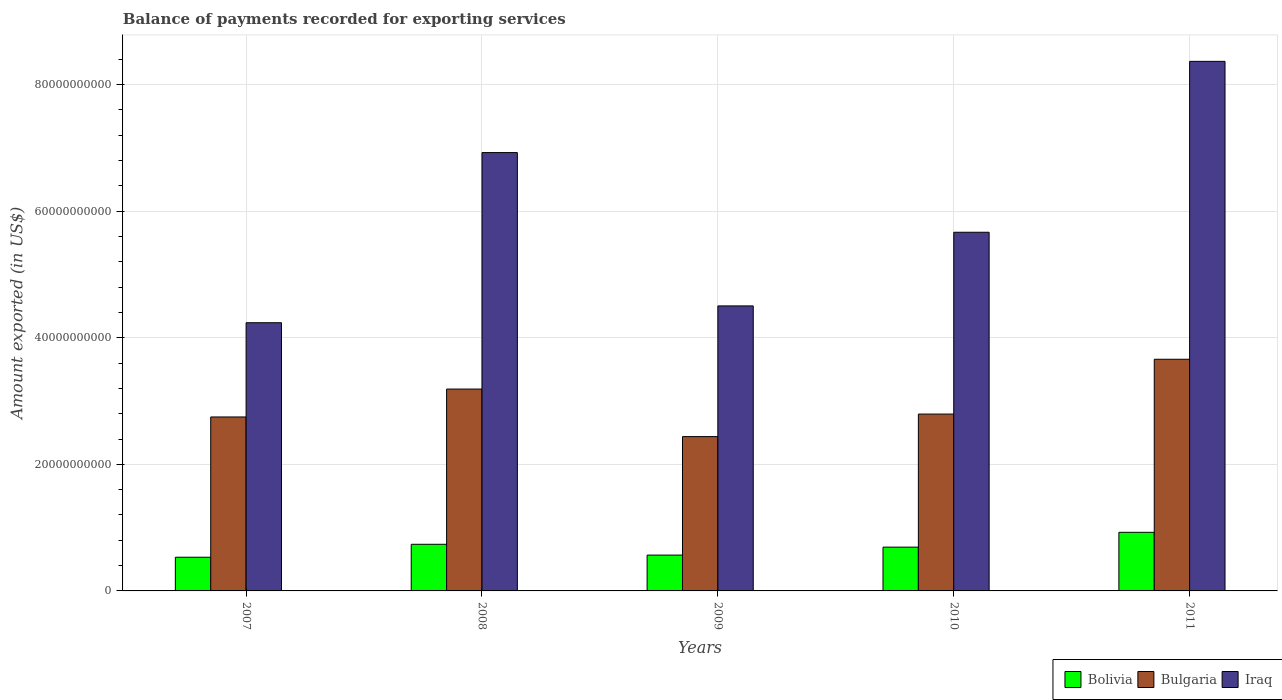Are the number of bars per tick equal to the number of legend labels?
Your answer should be compact. Yes. Are the number of bars on each tick of the X-axis equal?
Provide a short and direct response. Yes. What is the amount exported in Bolivia in 2008?
Keep it short and to the point. 7.37e+09. Across all years, what is the maximum amount exported in Bulgaria?
Provide a short and direct response. 3.66e+1. Across all years, what is the minimum amount exported in Bolivia?
Keep it short and to the point. 5.32e+09. In which year was the amount exported in Bulgaria maximum?
Offer a very short reply. 2011. What is the total amount exported in Bulgaria in the graph?
Your answer should be very brief. 1.48e+11. What is the difference between the amount exported in Bolivia in 2007 and that in 2009?
Offer a very short reply. -3.38e+08. What is the difference between the amount exported in Bulgaria in 2007 and the amount exported in Iraq in 2009?
Ensure brevity in your answer.  -1.75e+1. What is the average amount exported in Bolivia per year?
Your response must be concise. 6.91e+09. In the year 2007, what is the difference between the amount exported in Bolivia and amount exported in Iraq?
Your response must be concise. -3.71e+1. What is the ratio of the amount exported in Iraq in 2010 to that in 2011?
Keep it short and to the point. 0.68. Is the amount exported in Bulgaria in 2007 less than that in 2008?
Make the answer very short. Yes. Is the difference between the amount exported in Bolivia in 2007 and 2010 greater than the difference between the amount exported in Iraq in 2007 and 2010?
Make the answer very short. Yes. What is the difference between the highest and the second highest amount exported in Iraq?
Provide a succinct answer. 1.44e+1. What is the difference between the highest and the lowest amount exported in Iraq?
Give a very brief answer. 4.13e+1. What does the 3rd bar from the left in 2011 represents?
Ensure brevity in your answer.  Iraq. What does the 1st bar from the right in 2011 represents?
Provide a short and direct response. Iraq. Are the values on the major ticks of Y-axis written in scientific E-notation?
Provide a succinct answer. No. Does the graph contain grids?
Your answer should be very brief. Yes. How are the legend labels stacked?
Provide a succinct answer. Horizontal. What is the title of the graph?
Give a very brief answer. Balance of payments recorded for exporting services. What is the label or title of the Y-axis?
Make the answer very short. Amount exported (in US$). What is the Amount exported (in US$) of Bolivia in 2007?
Give a very brief answer. 5.32e+09. What is the Amount exported (in US$) in Bulgaria in 2007?
Your answer should be very brief. 2.75e+1. What is the Amount exported (in US$) in Iraq in 2007?
Offer a terse response. 4.24e+1. What is the Amount exported (in US$) of Bolivia in 2008?
Give a very brief answer. 7.37e+09. What is the Amount exported (in US$) of Bulgaria in 2008?
Your answer should be very brief. 3.19e+1. What is the Amount exported (in US$) in Iraq in 2008?
Make the answer very short. 6.93e+1. What is the Amount exported (in US$) in Bolivia in 2009?
Offer a terse response. 5.66e+09. What is the Amount exported (in US$) in Bulgaria in 2009?
Provide a short and direct response. 2.44e+1. What is the Amount exported (in US$) in Iraq in 2009?
Your answer should be very brief. 4.50e+1. What is the Amount exported (in US$) of Bolivia in 2010?
Provide a succinct answer. 6.92e+09. What is the Amount exported (in US$) in Bulgaria in 2010?
Ensure brevity in your answer.  2.79e+1. What is the Amount exported (in US$) of Iraq in 2010?
Your answer should be compact. 5.67e+1. What is the Amount exported (in US$) in Bolivia in 2011?
Give a very brief answer. 9.26e+09. What is the Amount exported (in US$) of Bulgaria in 2011?
Make the answer very short. 3.66e+1. What is the Amount exported (in US$) in Iraq in 2011?
Your response must be concise. 8.37e+1. Across all years, what is the maximum Amount exported (in US$) of Bolivia?
Your answer should be very brief. 9.26e+09. Across all years, what is the maximum Amount exported (in US$) of Bulgaria?
Your answer should be very brief. 3.66e+1. Across all years, what is the maximum Amount exported (in US$) of Iraq?
Ensure brevity in your answer.  8.37e+1. Across all years, what is the minimum Amount exported (in US$) of Bolivia?
Give a very brief answer. 5.32e+09. Across all years, what is the minimum Amount exported (in US$) in Bulgaria?
Your answer should be compact. 2.44e+1. Across all years, what is the minimum Amount exported (in US$) of Iraq?
Give a very brief answer. 4.24e+1. What is the total Amount exported (in US$) in Bolivia in the graph?
Offer a very short reply. 3.45e+1. What is the total Amount exported (in US$) in Bulgaria in the graph?
Provide a succinct answer. 1.48e+11. What is the total Amount exported (in US$) in Iraq in the graph?
Give a very brief answer. 2.97e+11. What is the difference between the Amount exported (in US$) of Bolivia in 2007 and that in 2008?
Provide a succinct answer. -2.04e+09. What is the difference between the Amount exported (in US$) of Bulgaria in 2007 and that in 2008?
Offer a very short reply. -4.41e+09. What is the difference between the Amount exported (in US$) in Iraq in 2007 and that in 2008?
Give a very brief answer. -2.69e+1. What is the difference between the Amount exported (in US$) of Bolivia in 2007 and that in 2009?
Provide a succinct answer. -3.38e+08. What is the difference between the Amount exported (in US$) in Bulgaria in 2007 and that in 2009?
Make the answer very short. 3.10e+09. What is the difference between the Amount exported (in US$) of Iraq in 2007 and that in 2009?
Your answer should be very brief. -2.66e+09. What is the difference between the Amount exported (in US$) in Bolivia in 2007 and that in 2010?
Offer a terse response. -1.59e+09. What is the difference between the Amount exported (in US$) in Bulgaria in 2007 and that in 2010?
Keep it short and to the point. -4.56e+08. What is the difference between the Amount exported (in US$) in Iraq in 2007 and that in 2010?
Make the answer very short. -1.43e+1. What is the difference between the Amount exported (in US$) of Bolivia in 2007 and that in 2011?
Your response must be concise. -3.94e+09. What is the difference between the Amount exported (in US$) of Bulgaria in 2007 and that in 2011?
Your response must be concise. -9.12e+09. What is the difference between the Amount exported (in US$) in Iraq in 2007 and that in 2011?
Give a very brief answer. -4.13e+1. What is the difference between the Amount exported (in US$) in Bolivia in 2008 and that in 2009?
Your answer should be very brief. 1.71e+09. What is the difference between the Amount exported (in US$) of Bulgaria in 2008 and that in 2009?
Offer a very short reply. 7.51e+09. What is the difference between the Amount exported (in US$) in Iraq in 2008 and that in 2009?
Your response must be concise. 2.42e+1. What is the difference between the Amount exported (in US$) of Bolivia in 2008 and that in 2010?
Provide a short and direct response. 4.51e+08. What is the difference between the Amount exported (in US$) of Bulgaria in 2008 and that in 2010?
Offer a very short reply. 3.95e+09. What is the difference between the Amount exported (in US$) of Iraq in 2008 and that in 2010?
Give a very brief answer. 1.26e+1. What is the difference between the Amount exported (in US$) in Bolivia in 2008 and that in 2011?
Ensure brevity in your answer.  -1.89e+09. What is the difference between the Amount exported (in US$) in Bulgaria in 2008 and that in 2011?
Provide a short and direct response. -4.71e+09. What is the difference between the Amount exported (in US$) of Iraq in 2008 and that in 2011?
Your response must be concise. -1.44e+1. What is the difference between the Amount exported (in US$) in Bolivia in 2009 and that in 2010?
Your answer should be compact. -1.26e+09. What is the difference between the Amount exported (in US$) of Bulgaria in 2009 and that in 2010?
Provide a short and direct response. -3.56e+09. What is the difference between the Amount exported (in US$) in Iraq in 2009 and that in 2010?
Offer a very short reply. -1.16e+1. What is the difference between the Amount exported (in US$) in Bolivia in 2009 and that in 2011?
Your answer should be very brief. -3.60e+09. What is the difference between the Amount exported (in US$) in Bulgaria in 2009 and that in 2011?
Provide a succinct answer. -1.22e+1. What is the difference between the Amount exported (in US$) in Iraq in 2009 and that in 2011?
Provide a short and direct response. -3.86e+1. What is the difference between the Amount exported (in US$) of Bolivia in 2010 and that in 2011?
Provide a succinct answer. -2.34e+09. What is the difference between the Amount exported (in US$) in Bulgaria in 2010 and that in 2011?
Provide a succinct answer. -8.66e+09. What is the difference between the Amount exported (in US$) of Iraq in 2010 and that in 2011?
Your response must be concise. -2.70e+1. What is the difference between the Amount exported (in US$) in Bolivia in 2007 and the Amount exported (in US$) in Bulgaria in 2008?
Ensure brevity in your answer.  -2.66e+1. What is the difference between the Amount exported (in US$) of Bolivia in 2007 and the Amount exported (in US$) of Iraq in 2008?
Provide a short and direct response. -6.39e+1. What is the difference between the Amount exported (in US$) of Bulgaria in 2007 and the Amount exported (in US$) of Iraq in 2008?
Your answer should be very brief. -4.18e+1. What is the difference between the Amount exported (in US$) in Bolivia in 2007 and the Amount exported (in US$) in Bulgaria in 2009?
Provide a succinct answer. -1.91e+1. What is the difference between the Amount exported (in US$) in Bolivia in 2007 and the Amount exported (in US$) in Iraq in 2009?
Provide a short and direct response. -3.97e+1. What is the difference between the Amount exported (in US$) of Bulgaria in 2007 and the Amount exported (in US$) of Iraq in 2009?
Offer a terse response. -1.75e+1. What is the difference between the Amount exported (in US$) in Bolivia in 2007 and the Amount exported (in US$) in Bulgaria in 2010?
Keep it short and to the point. -2.26e+1. What is the difference between the Amount exported (in US$) in Bolivia in 2007 and the Amount exported (in US$) in Iraq in 2010?
Keep it short and to the point. -5.13e+1. What is the difference between the Amount exported (in US$) of Bulgaria in 2007 and the Amount exported (in US$) of Iraq in 2010?
Keep it short and to the point. -2.92e+1. What is the difference between the Amount exported (in US$) in Bolivia in 2007 and the Amount exported (in US$) in Bulgaria in 2011?
Your answer should be compact. -3.13e+1. What is the difference between the Amount exported (in US$) in Bolivia in 2007 and the Amount exported (in US$) in Iraq in 2011?
Your answer should be very brief. -7.84e+1. What is the difference between the Amount exported (in US$) of Bulgaria in 2007 and the Amount exported (in US$) of Iraq in 2011?
Give a very brief answer. -5.62e+1. What is the difference between the Amount exported (in US$) of Bolivia in 2008 and the Amount exported (in US$) of Bulgaria in 2009?
Keep it short and to the point. -1.70e+1. What is the difference between the Amount exported (in US$) in Bolivia in 2008 and the Amount exported (in US$) in Iraq in 2009?
Keep it short and to the point. -3.77e+1. What is the difference between the Amount exported (in US$) of Bulgaria in 2008 and the Amount exported (in US$) of Iraq in 2009?
Provide a short and direct response. -1.31e+1. What is the difference between the Amount exported (in US$) of Bolivia in 2008 and the Amount exported (in US$) of Bulgaria in 2010?
Offer a very short reply. -2.06e+1. What is the difference between the Amount exported (in US$) of Bolivia in 2008 and the Amount exported (in US$) of Iraq in 2010?
Offer a terse response. -4.93e+1. What is the difference between the Amount exported (in US$) of Bulgaria in 2008 and the Amount exported (in US$) of Iraq in 2010?
Your answer should be compact. -2.48e+1. What is the difference between the Amount exported (in US$) of Bolivia in 2008 and the Amount exported (in US$) of Bulgaria in 2011?
Keep it short and to the point. -2.92e+1. What is the difference between the Amount exported (in US$) of Bolivia in 2008 and the Amount exported (in US$) of Iraq in 2011?
Your answer should be very brief. -7.63e+1. What is the difference between the Amount exported (in US$) in Bulgaria in 2008 and the Amount exported (in US$) in Iraq in 2011?
Your answer should be very brief. -5.18e+1. What is the difference between the Amount exported (in US$) in Bolivia in 2009 and the Amount exported (in US$) in Bulgaria in 2010?
Your answer should be compact. -2.23e+1. What is the difference between the Amount exported (in US$) of Bolivia in 2009 and the Amount exported (in US$) of Iraq in 2010?
Provide a short and direct response. -5.10e+1. What is the difference between the Amount exported (in US$) in Bulgaria in 2009 and the Amount exported (in US$) in Iraq in 2010?
Offer a very short reply. -3.23e+1. What is the difference between the Amount exported (in US$) in Bolivia in 2009 and the Amount exported (in US$) in Bulgaria in 2011?
Give a very brief answer. -3.09e+1. What is the difference between the Amount exported (in US$) in Bolivia in 2009 and the Amount exported (in US$) in Iraq in 2011?
Your response must be concise. -7.80e+1. What is the difference between the Amount exported (in US$) in Bulgaria in 2009 and the Amount exported (in US$) in Iraq in 2011?
Make the answer very short. -5.93e+1. What is the difference between the Amount exported (in US$) of Bolivia in 2010 and the Amount exported (in US$) of Bulgaria in 2011?
Give a very brief answer. -2.97e+1. What is the difference between the Amount exported (in US$) in Bolivia in 2010 and the Amount exported (in US$) in Iraq in 2011?
Give a very brief answer. -7.68e+1. What is the difference between the Amount exported (in US$) in Bulgaria in 2010 and the Amount exported (in US$) in Iraq in 2011?
Make the answer very short. -5.57e+1. What is the average Amount exported (in US$) in Bolivia per year?
Provide a succinct answer. 6.91e+09. What is the average Amount exported (in US$) in Bulgaria per year?
Offer a terse response. 2.97e+1. What is the average Amount exported (in US$) in Iraq per year?
Ensure brevity in your answer.  5.94e+1. In the year 2007, what is the difference between the Amount exported (in US$) of Bolivia and Amount exported (in US$) of Bulgaria?
Provide a short and direct response. -2.22e+1. In the year 2007, what is the difference between the Amount exported (in US$) of Bolivia and Amount exported (in US$) of Iraq?
Offer a terse response. -3.71e+1. In the year 2007, what is the difference between the Amount exported (in US$) of Bulgaria and Amount exported (in US$) of Iraq?
Your response must be concise. -1.49e+1. In the year 2008, what is the difference between the Amount exported (in US$) of Bolivia and Amount exported (in US$) of Bulgaria?
Offer a very short reply. -2.45e+1. In the year 2008, what is the difference between the Amount exported (in US$) of Bolivia and Amount exported (in US$) of Iraq?
Keep it short and to the point. -6.19e+1. In the year 2008, what is the difference between the Amount exported (in US$) in Bulgaria and Amount exported (in US$) in Iraq?
Keep it short and to the point. -3.74e+1. In the year 2009, what is the difference between the Amount exported (in US$) in Bolivia and Amount exported (in US$) in Bulgaria?
Give a very brief answer. -1.87e+1. In the year 2009, what is the difference between the Amount exported (in US$) of Bolivia and Amount exported (in US$) of Iraq?
Provide a succinct answer. -3.94e+1. In the year 2009, what is the difference between the Amount exported (in US$) in Bulgaria and Amount exported (in US$) in Iraq?
Your answer should be compact. -2.07e+1. In the year 2010, what is the difference between the Amount exported (in US$) in Bolivia and Amount exported (in US$) in Bulgaria?
Keep it short and to the point. -2.10e+1. In the year 2010, what is the difference between the Amount exported (in US$) of Bolivia and Amount exported (in US$) of Iraq?
Your answer should be compact. -4.98e+1. In the year 2010, what is the difference between the Amount exported (in US$) of Bulgaria and Amount exported (in US$) of Iraq?
Provide a short and direct response. -2.87e+1. In the year 2011, what is the difference between the Amount exported (in US$) in Bolivia and Amount exported (in US$) in Bulgaria?
Keep it short and to the point. -2.73e+1. In the year 2011, what is the difference between the Amount exported (in US$) in Bolivia and Amount exported (in US$) in Iraq?
Offer a very short reply. -7.44e+1. In the year 2011, what is the difference between the Amount exported (in US$) in Bulgaria and Amount exported (in US$) in Iraq?
Offer a terse response. -4.71e+1. What is the ratio of the Amount exported (in US$) of Bolivia in 2007 to that in 2008?
Keep it short and to the point. 0.72. What is the ratio of the Amount exported (in US$) in Bulgaria in 2007 to that in 2008?
Offer a terse response. 0.86. What is the ratio of the Amount exported (in US$) in Iraq in 2007 to that in 2008?
Provide a short and direct response. 0.61. What is the ratio of the Amount exported (in US$) in Bolivia in 2007 to that in 2009?
Your answer should be very brief. 0.94. What is the ratio of the Amount exported (in US$) in Bulgaria in 2007 to that in 2009?
Your response must be concise. 1.13. What is the ratio of the Amount exported (in US$) in Iraq in 2007 to that in 2009?
Ensure brevity in your answer.  0.94. What is the ratio of the Amount exported (in US$) in Bolivia in 2007 to that in 2010?
Offer a terse response. 0.77. What is the ratio of the Amount exported (in US$) of Bulgaria in 2007 to that in 2010?
Your answer should be compact. 0.98. What is the ratio of the Amount exported (in US$) of Iraq in 2007 to that in 2010?
Your response must be concise. 0.75. What is the ratio of the Amount exported (in US$) of Bolivia in 2007 to that in 2011?
Provide a short and direct response. 0.57. What is the ratio of the Amount exported (in US$) in Bulgaria in 2007 to that in 2011?
Offer a terse response. 0.75. What is the ratio of the Amount exported (in US$) in Iraq in 2007 to that in 2011?
Offer a terse response. 0.51. What is the ratio of the Amount exported (in US$) of Bolivia in 2008 to that in 2009?
Your answer should be compact. 1.3. What is the ratio of the Amount exported (in US$) of Bulgaria in 2008 to that in 2009?
Offer a terse response. 1.31. What is the ratio of the Amount exported (in US$) of Iraq in 2008 to that in 2009?
Your answer should be very brief. 1.54. What is the ratio of the Amount exported (in US$) in Bolivia in 2008 to that in 2010?
Your answer should be compact. 1.07. What is the ratio of the Amount exported (in US$) of Bulgaria in 2008 to that in 2010?
Your answer should be very brief. 1.14. What is the ratio of the Amount exported (in US$) of Iraq in 2008 to that in 2010?
Offer a terse response. 1.22. What is the ratio of the Amount exported (in US$) in Bolivia in 2008 to that in 2011?
Provide a short and direct response. 0.8. What is the ratio of the Amount exported (in US$) in Bulgaria in 2008 to that in 2011?
Your answer should be very brief. 0.87. What is the ratio of the Amount exported (in US$) in Iraq in 2008 to that in 2011?
Ensure brevity in your answer.  0.83. What is the ratio of the Amount exported (in US$) in Bolivia in 2009 to that in 2010?
Your answer should be compact. 0.82. What is the ratio of the Amount exported (in US$) of Bulgaria in 2009 to that in 2010?
Give a very brief answer. 0.87. What is the ratio of the Amount exported (in US$) in Iraq in 2009 to that in 2010?
Make the answer very short. 0.79. What is the ratio of the Amount exported (in US$) in Bolivia in 2009 to that in 2011?
Give a very brief answer. 0.61. What is the ratio of the Amount exported (in US$) of Bulgaria in 2009 to that in 2011?
Your response must be concise. 0.67. What is the ratio of the Amount exported (in US$) in Iraq in 2009 to that in 2011?
Your answer should be very brief. 0.54. What is the ratio of the Amount exported (in US$) in Bolivia in 2010 to that in 2011?
Provide a succinct answer. 0.75. What is the ratio of the Amount exported (in US$) of Bulgaria in 2010 to that in 2011?
Ensure brevity in your answer.  0.76. What is the ratio of the Amount exported (in US$) in Iraq in 2010 to that in 2011?
Your answer should be very brief. 0.68. What is the difference between the highest and the second highest Amount exported (in US$) in Bolivia?
Make the answer very short. 1.89e+09. What is the difference between the highest and the second highest Amount exported (in US$) in Bulgaria?
Your response must be concise. 4.71e+09. What is the difference between the highest and the second highest Amount exported (in US$) of Iraq?
Offer a very short reply. 1.44e+1. What is the difference between the highest and the lowest Amount exported (in US$) in Bolivia?
Offer a very short reply. 3.94e+09. What is the difference between the highest and the lowest Amount exported (in US$) in Bulgaria?
Your response must be concise. 1.22e+1. What is the difference between the highest and the lowest Amount exported (in US$) in Iraq?
Your answer should be compact. 4.13e+1. 